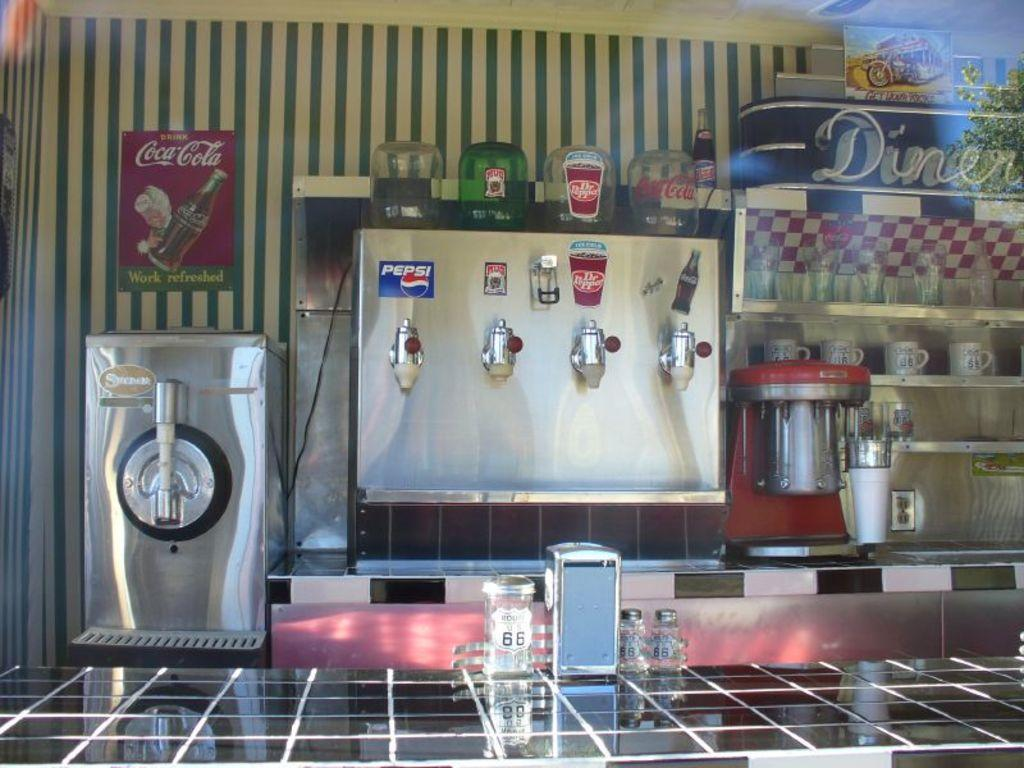<image>
Describe the image concisely. a Pepsi drink on a silver object with other sodas 